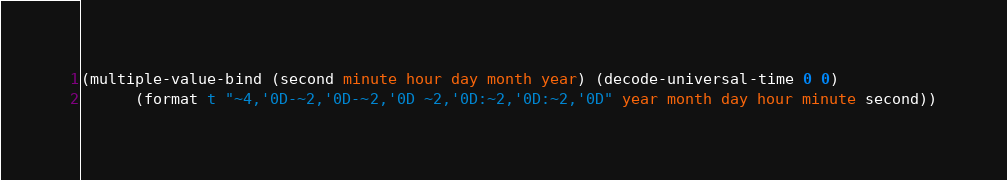Convert code to text. <code><loc_0><loc_0><loc_500><loc_500><_Lisp_>(multiple-value-bind (second minute hour day month year) (decode-universal-time 0 0)
 	  (format t "~4,'0D-~2,'0D-~2,'0D ~2,'0D:~2,'0D:~2,'0D" year month day hour minute second))
</code> 